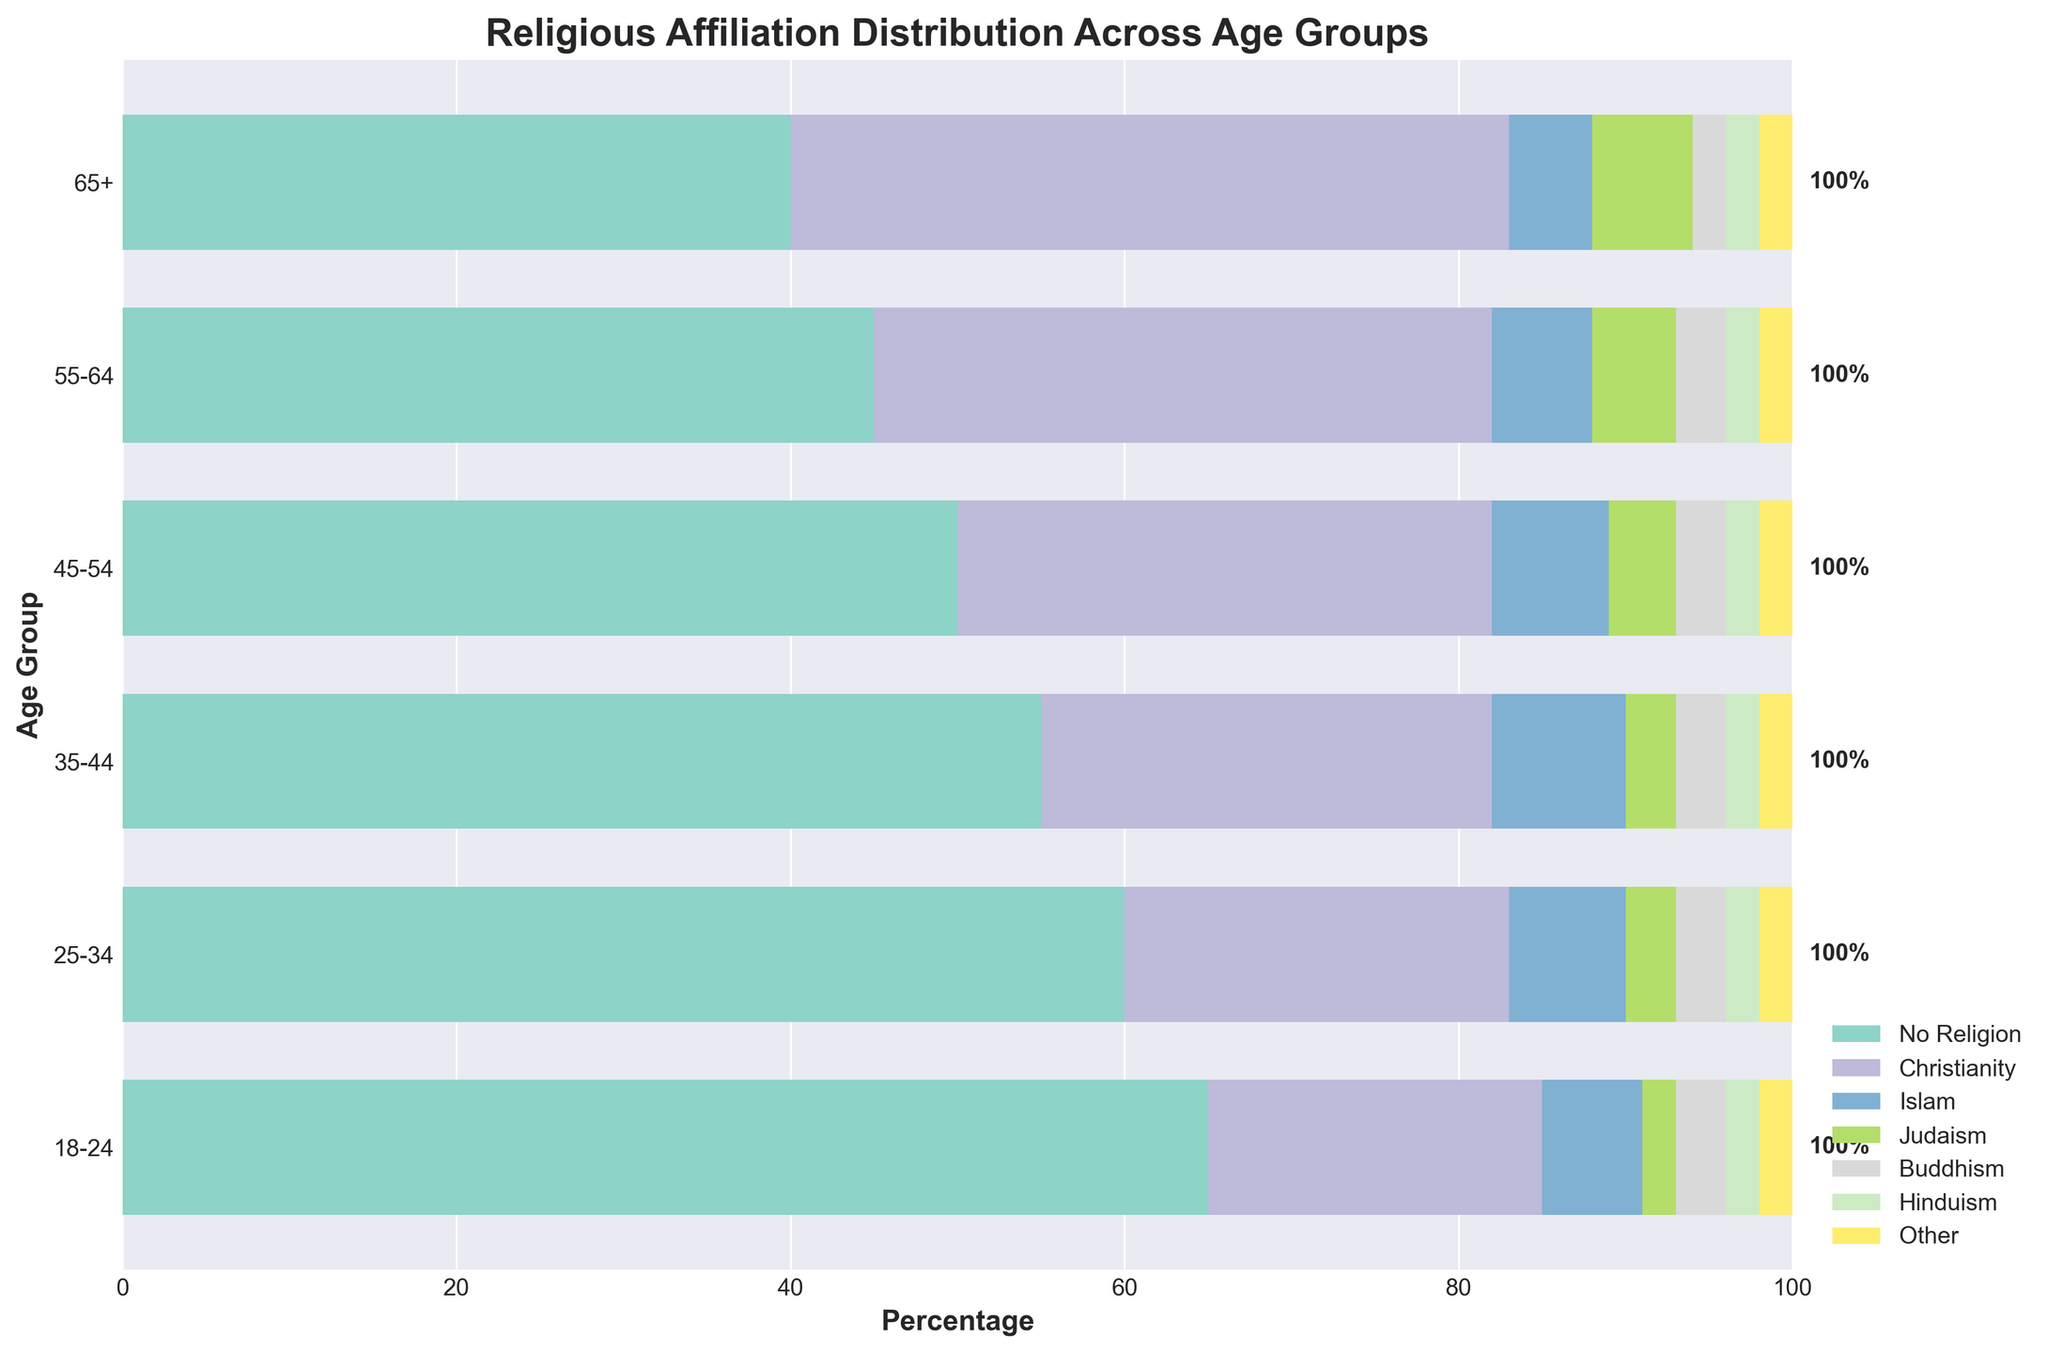what is the title of the plot? The title is displayed at the top of the figure. It is "Religious Affiliation Distribution Across Age Groups".
Answer: Religious Affiliation Distribution Across Age Groups What is the percentage of people with no religion in the 18-24 age group? Look at the horizontal bar corresponding to the 18-24 age group. The segment representing "No Religion" reaches 65%.
Answer: 65% Which age group has the largest percentage of people following Christianity? Look for the age group with the widest segment for Christianity. For the 65+ age group, the Christianity segment is the largest, reaching 43%.
Answer: 65+ What's the difference in the percentage of people with no religion between the 18-24 and 65+ age groups? The percentage for the 18-24 age group is 65%. For the 65+ age group, it's 40%. The difference is 65% - 40% = 25%.
Answer: 25% Which religion has the smallest percentage in all age groups? Check the percentages for each religion in all age groups. Hinduism has 2% for every age group, which is the smallest consistent percentage.
Answer: Hinduism What is the total percentage of people with no religion and Christianity in the 35-44 age group? For the 35-44 age group, the percentage of "No Religion" is 55%, and for Christianity, it is 27%. Summing these up gives 55% + 27% = 82%.
Answer: 82% Among the 25-34 age group, how much more prevalent is "No Religion" compared to Buddhism? "No Religion" is 60% for the 25-34 age group, while Buddhism is 3%. The difference is 60% - 3% = 57%.
Answer: 57% In which two age groups does the percentage of Islam remain constant, and what is the value? Look at the horizontal bars for all age groups. Islam percentages remain constant at 6% for the 18-24 and 55-64 age groups.
Answer: 18-24, 55-64; 6% What trend is observed in the percentage of people following Judaism as age increases? Observe the segments for Judaism across age groups. The percentage increases steadily from 2% in the 18-24 age group to 6% in the 65+ age group.
Answer: Increasing trend What is the cumulative percentage for all non-Christian religions in the 45-54 age group? Add the percentage for Islam (7%), Judaism (4%), Buddhism (3%), Hinduism (2%), and Other religions (2%) in the 45-54 age group. The total is 7% + 4% + 3% + 2% + 2% = 18%.
Answer: 18% 